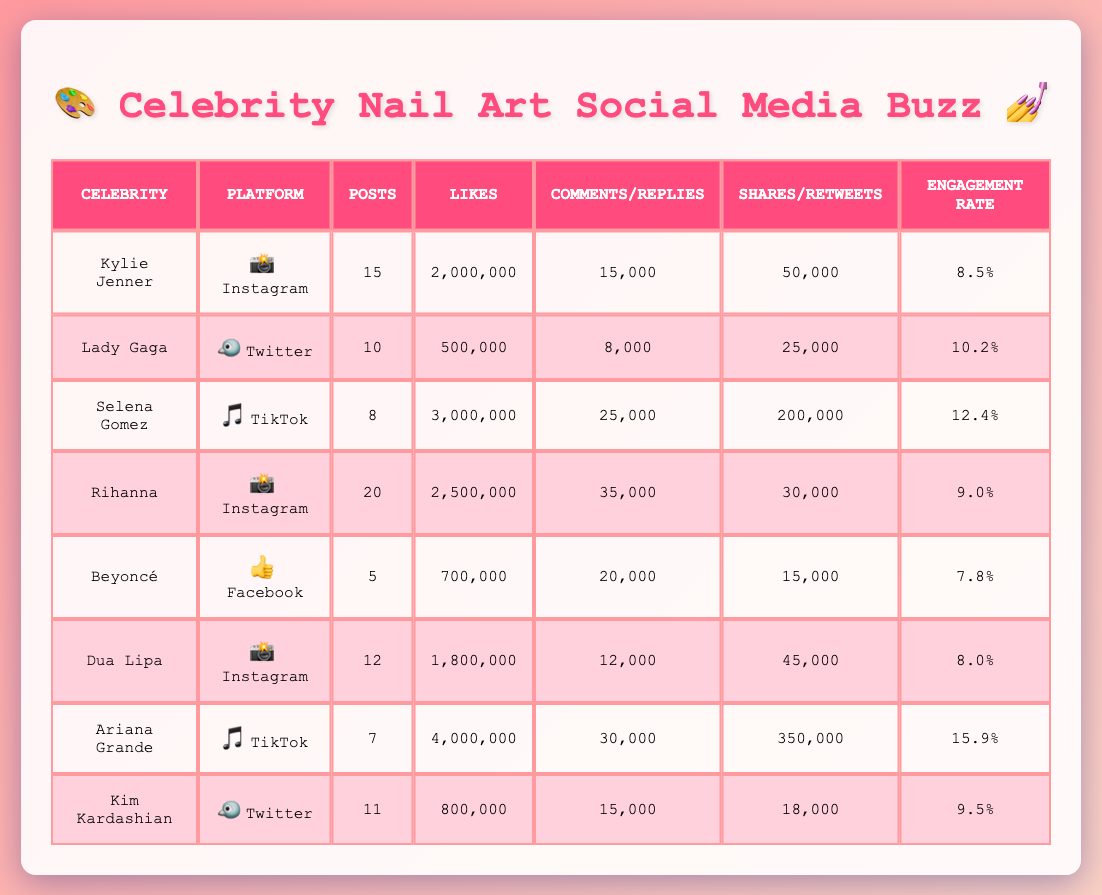What is the engagement rate for Ariana Grande's TikTok posts? According to the table, Ariana Grande has an engagement rate of 15.9% for her TikTok posts.
Answer: 15.9% Which celebrity has the highest number of likes on Instagram posts? From the table, Rihanna has the highest likes on Instagram with 2,500,000 likes.
Answer: Rihanna How many total posts did Selena Gomez and Ariana Grande make combined? Selena Gomez made 8 posts and Ariana Grande made 7 posts. Adding these together gives 8 + 7 = 15 total posts.
Answer: 15 Is Beyoncé’s engagement rate higher than Kylie Jenner’s? Beyoncé has an engagement rate of 7.8% while Kylie Jenner has an engagement rate of 8.5%. Since 7.8% is less than 8.5%, the statement is false.
Answer: No What is the average engagement rate for the TikTok posts of Selena Gomez and Ariana Grande? Selena Gomez's engagement rate is 12.4% and Ariana Grande's is 15.9%. The average is calculated as (12.4 + 15.9) / 2 = 14.15%.
Answer: 14.15% How many more comments did Rihanna receive than Dua Lipa? Rihanna received 35,000 comments while Dua Lipa received 12,000 comments. The difference is 35,000 - 12,000 = 23,000 comments.
Answer: 23,000 Which platform had the most shares for nail art posts? Ariana Grande on TikTok had the most shares with 350,000.
Answer: TikTok How many likes did Kim Kardashian's Twitter posts receive in total? Kim Kardashian received 800,000 likes for her Twitter posts.
Answer: 800,000 Who had the lowest engagement rate among the celebrities listed? From the table, Beyoncé has the lowest engagement rate at 7.8%.
Answer: Beyoncé If we rank the celebrities by the number of likes received, who is in fifth place? By analyzing the likes in descending order: 4,000,000 (Ariana Grande), 3,000,000 (Selena Gomez), 2,500,000 (Rihanna), 2,000,000 (Kylie Jenner), and 1,800,000 (Dua Lipa), thus getting 1,800,000 puts Dua Lipa in fifth.
Answer: Dua Lipa 